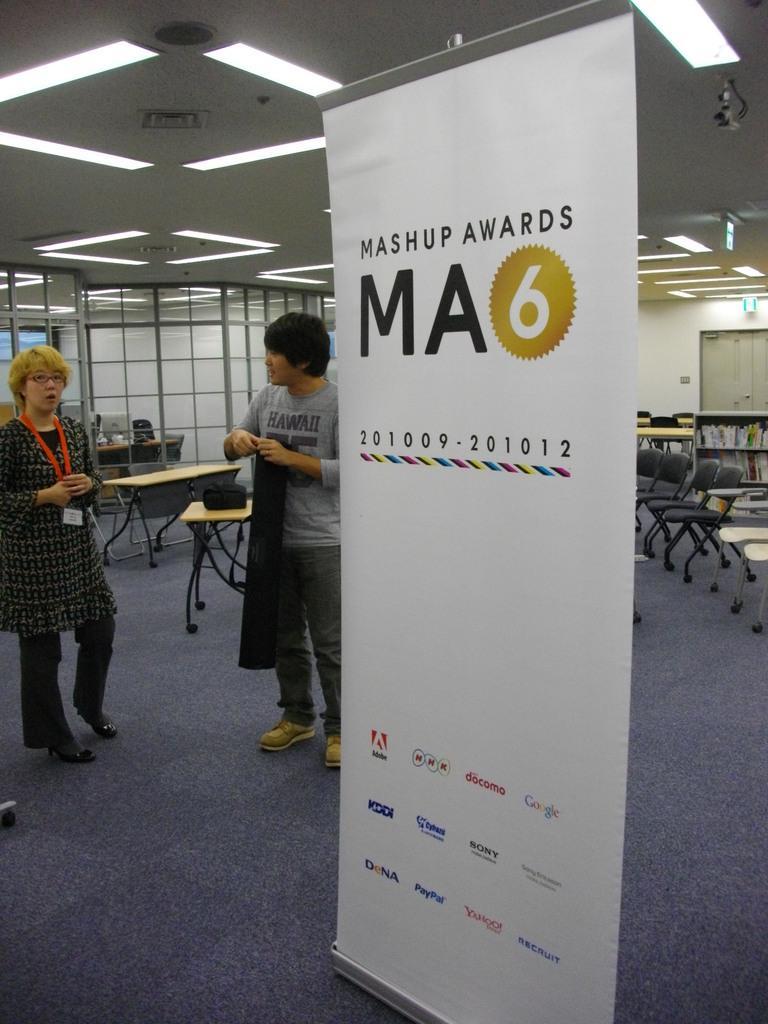Can you describe this image briefly? There is a man and a woman standing on the floor. Here we can see a banner, chairs, rack, books, and tables. In the background we can see glasses, lights, boards, door, and a wall. 